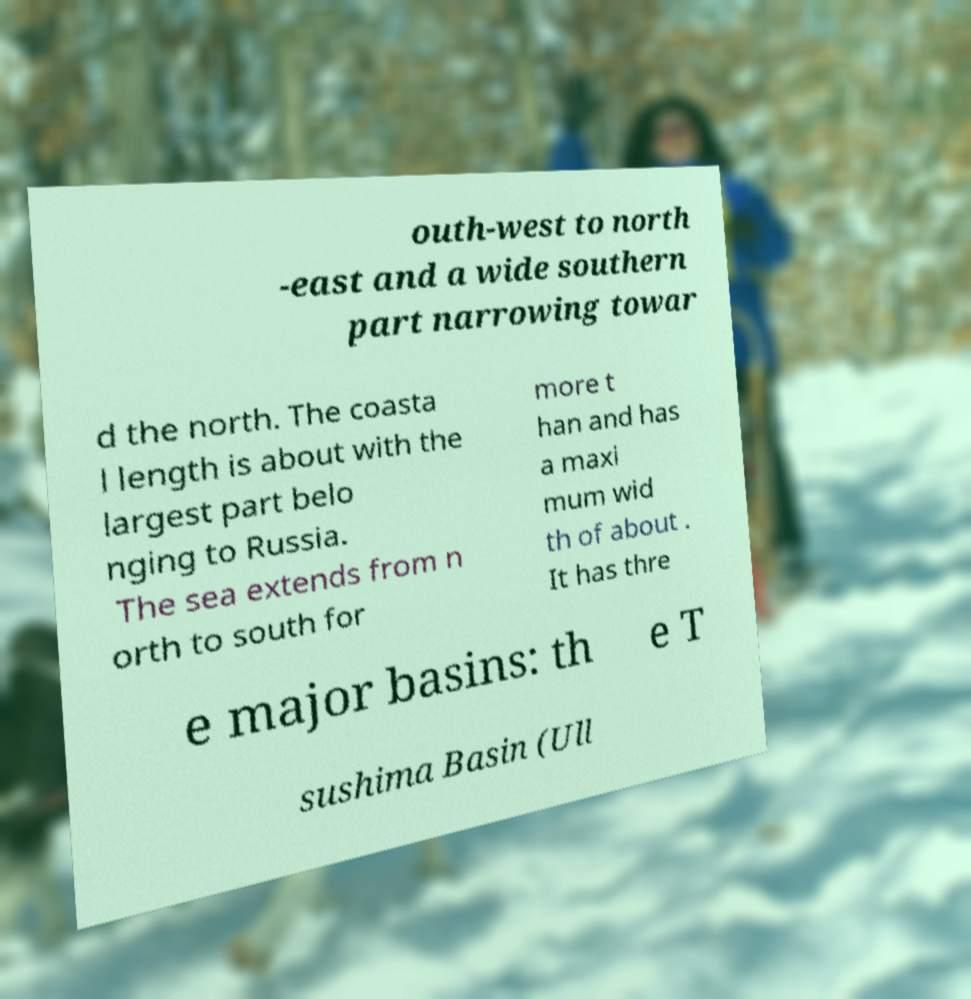There's text embedded in this image that I need extracted. Can you transcribe it verbatim? outh-west to north -east and a wide southern part narrowing towar d the north. The coasta l length is about with the largest part belo nging to Russia. The sea extends from n orth to south for more t han and has a maxi mum wid th of about . It has thre e major basins: th e T sushima Basin (Ull 